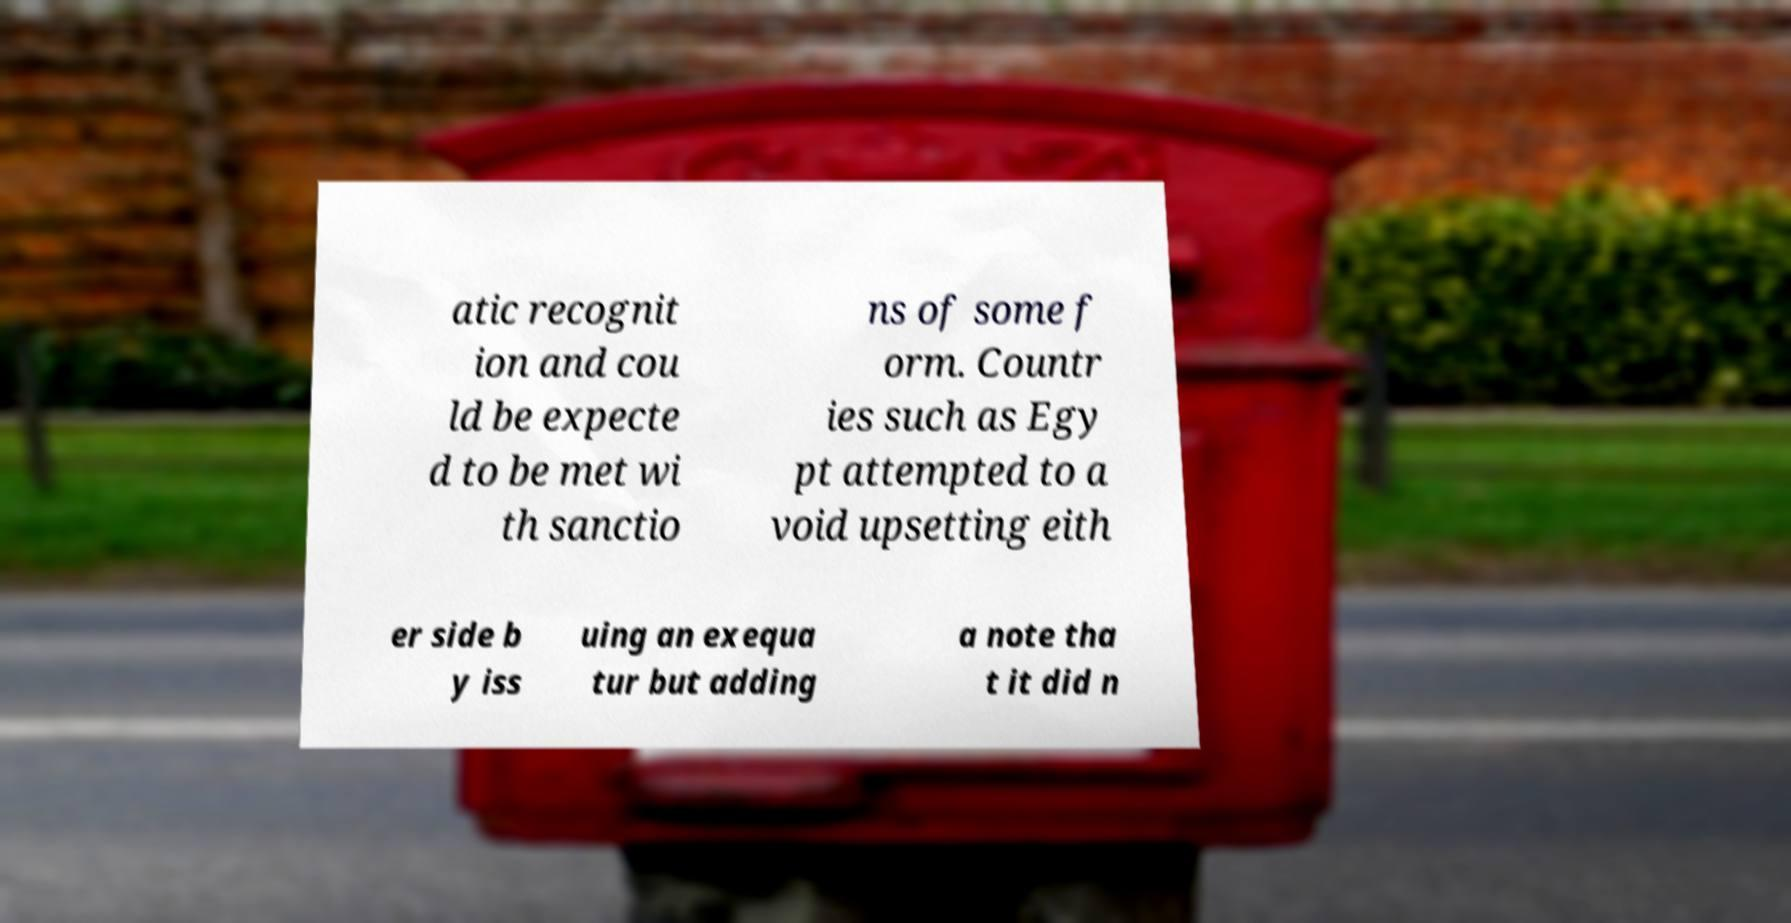Could you extract and type out the text from this image? atic recognit ion and cou ld be expecte d to be met wi th sanctio ns of some f orm. Countr ies such as Egy pt attempted to a void upsetting eith er side b y iss uing an exequa tur but adding a note tha t it did n 